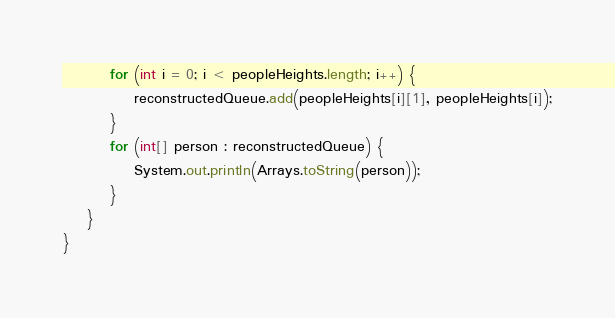<code> <loc_0><loc_0><loc_500><loc_500><_Java_>        for (int i = 0; i < peopleHeights.length; i++) {
            reconstructedQueue.add(peopleHeights[i][1], peopleHeights[i]);
        }
        for (int[] person : reconstructedQueue) {
            System.out.println(Arrays.toString(person));
        }
    }
}</code> 